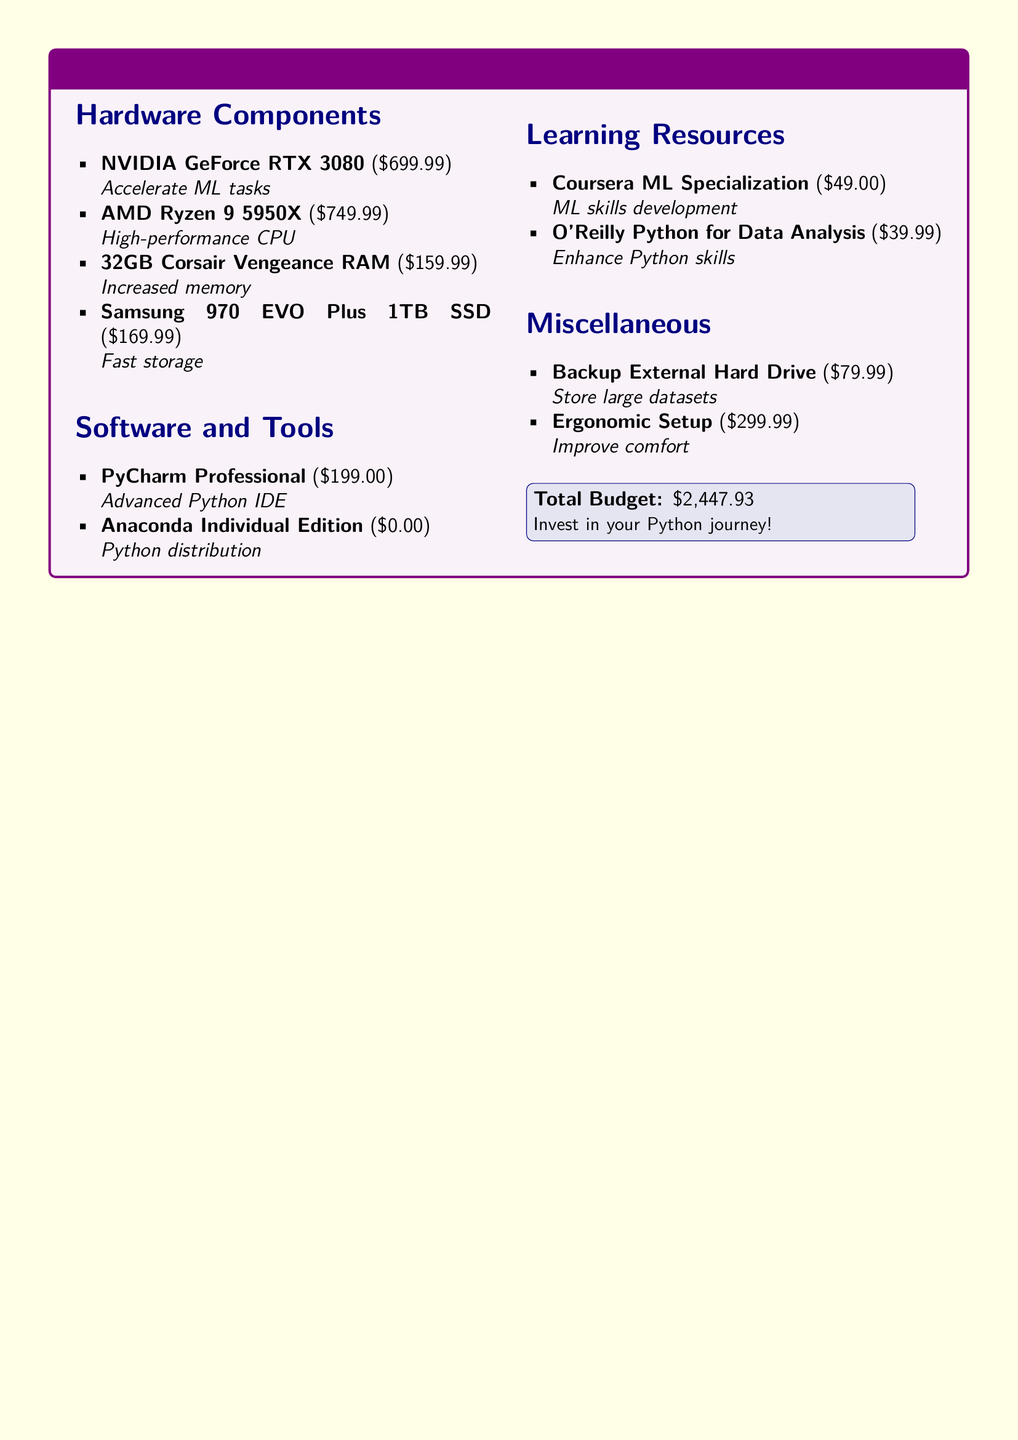What is the total budget? The total budget is listed at the bottom of the document as the sum of all items, which is \$2,447.93.
Answer: $2,447.93 How much does the NVIDIA GeForce RTX 3080 cost? The cost of the NVIDIA GeForce RTX 3080 is specified in the hardware components section.
Answer: $699.99 What learning resource focuses on machine learning skills? The learning resource section includes Coursera ML Specialization, which is specific to machine learning.
Answer: Coursera ML Specialization How many gigabytes of RAM is being proposed for the upgrade? The budget specifies the purchase of 32GB Corsair Vengeance RAM in the hardware components section.
Answer: 32GB What is the price of the ergonomic setup? The price for the ergonomic setup is mentioned in the miscellaneous section of the budget.
Answer: $299.99 Which software listed has a cost of zero? Anaconda Individual Edition is the only software in the document with a cost of zero dollars.
Answer: Anaconda Individual Edition What component is aimed to accelerate ML tasks? The component designed to accelerate machine learning tasks is the NVIDIA GeForce RTX 3080.
Answer: NVIDIA GeForce RTX 3080 How much does the Samsung 970 EVO Plus 1TB SSD cost? The cost of the Samsung 970 EVO Plus 1TB SSD is provided in the hardware components section.
Answer: $169.99 What type of drive is included for storing large datasets? The document mentions a backup external hard drive for this purpose in the miscellaneous section.
Answer: Backup External Hard Drive 